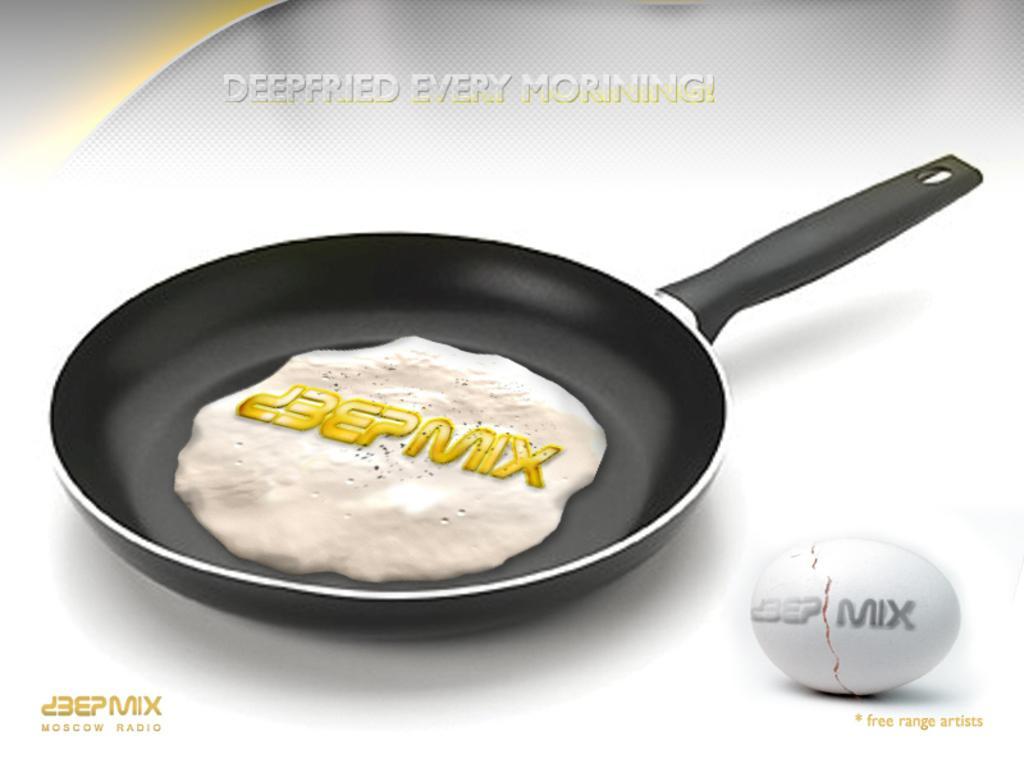In one or two sentences, can you explain what this image depicts? This might be an animation, in this image in the center there is a pan and in the pan there is some food and there is text. On the right side of the image there is an egg. 